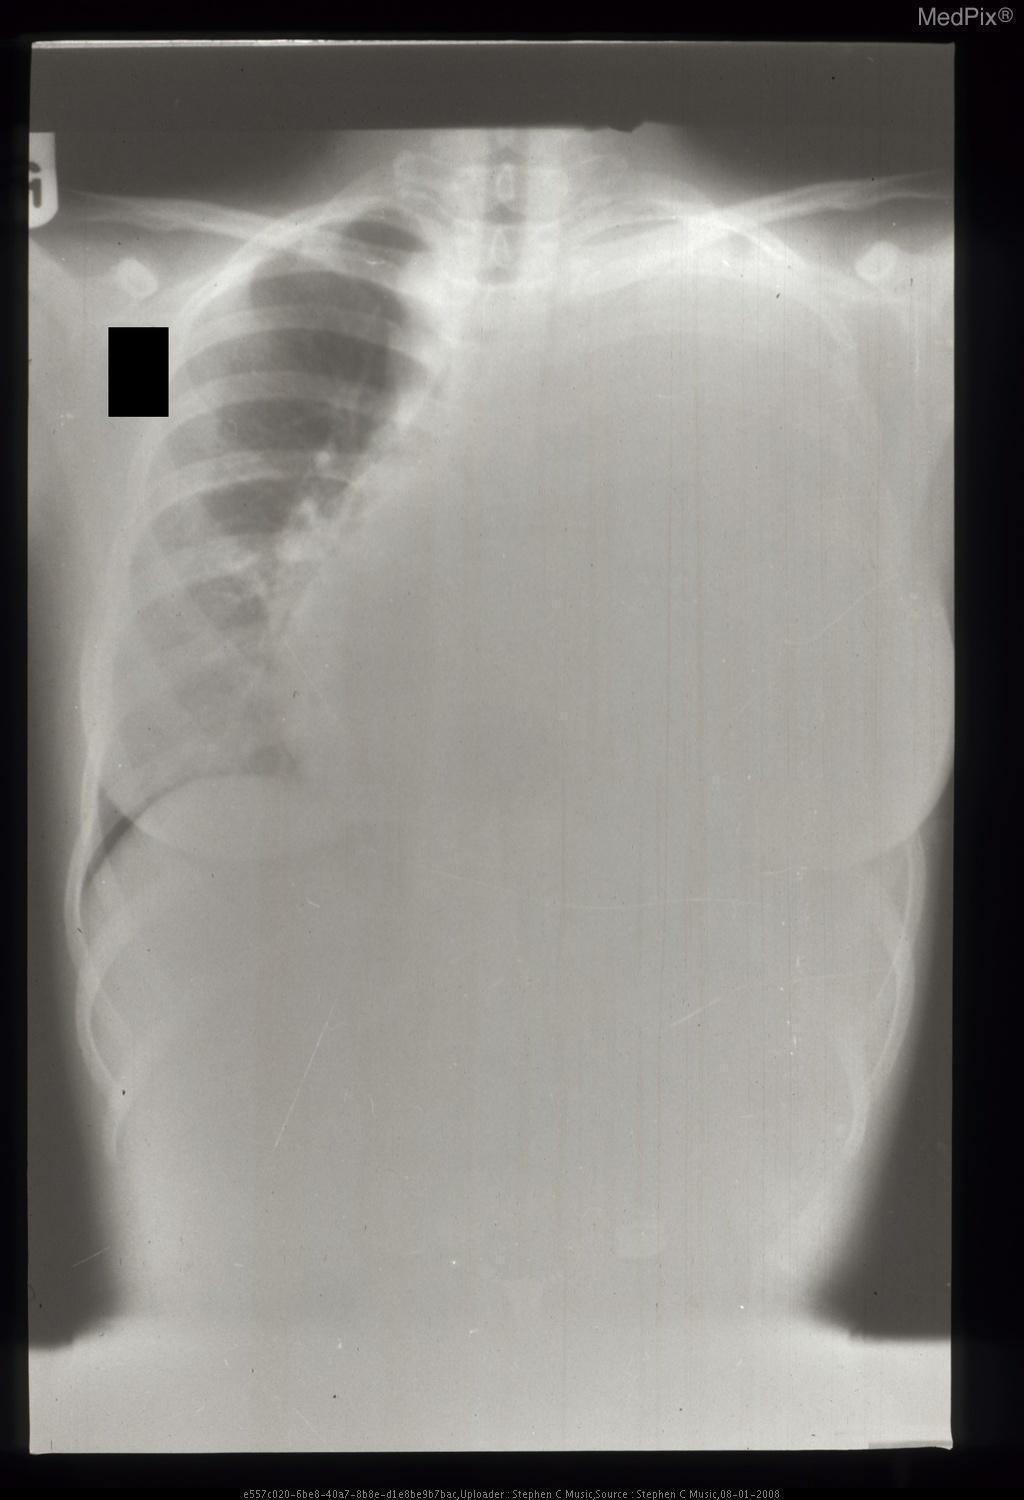Is there a mediastinal shift?
Quick response, please. Yes. Is this a solid or cystic lesion?
Write a very short answer. Solid. Is the lesion a solid or cystic lesion?
Short answer required. Solid. Can you see all of the ribs on the left side?
Answer briefly. No. Can the left ribs be evaluated?
Be succinct. No. Can a pleural effusion be appreciated on the right side?
Answer briefly. No. Is there a right-sided pleural effusion?
Short answer required. No. 